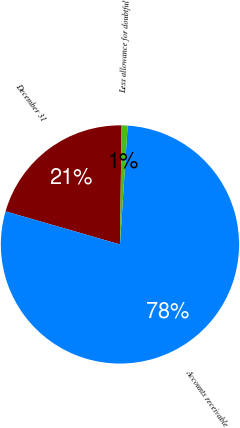Convert chart to OTSL. <chart><loc_0><loc_0><loc_500><loc_500><pie_chart><fcel>December 31<fcel>Accounts receivable<fcel>Less allowance for doubtful<nl><fcel>20.74%<fcel>78.45%<fcel>0.81%<nl></chart> 